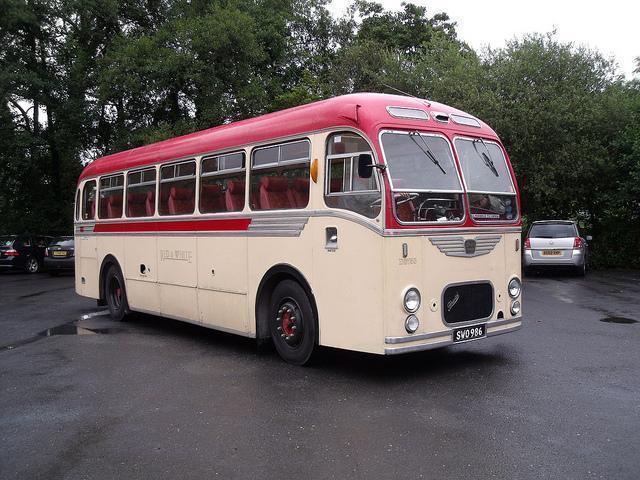What is the purpose of this vehicle?
Pick the right solution, then justify: 'Answer: answer
Rationale: rationale.'
Options: School bus, speed, carry cargo, carry passengers. Answer: carry passengers.
Rationale: It has a large number of seats and is a bus. 